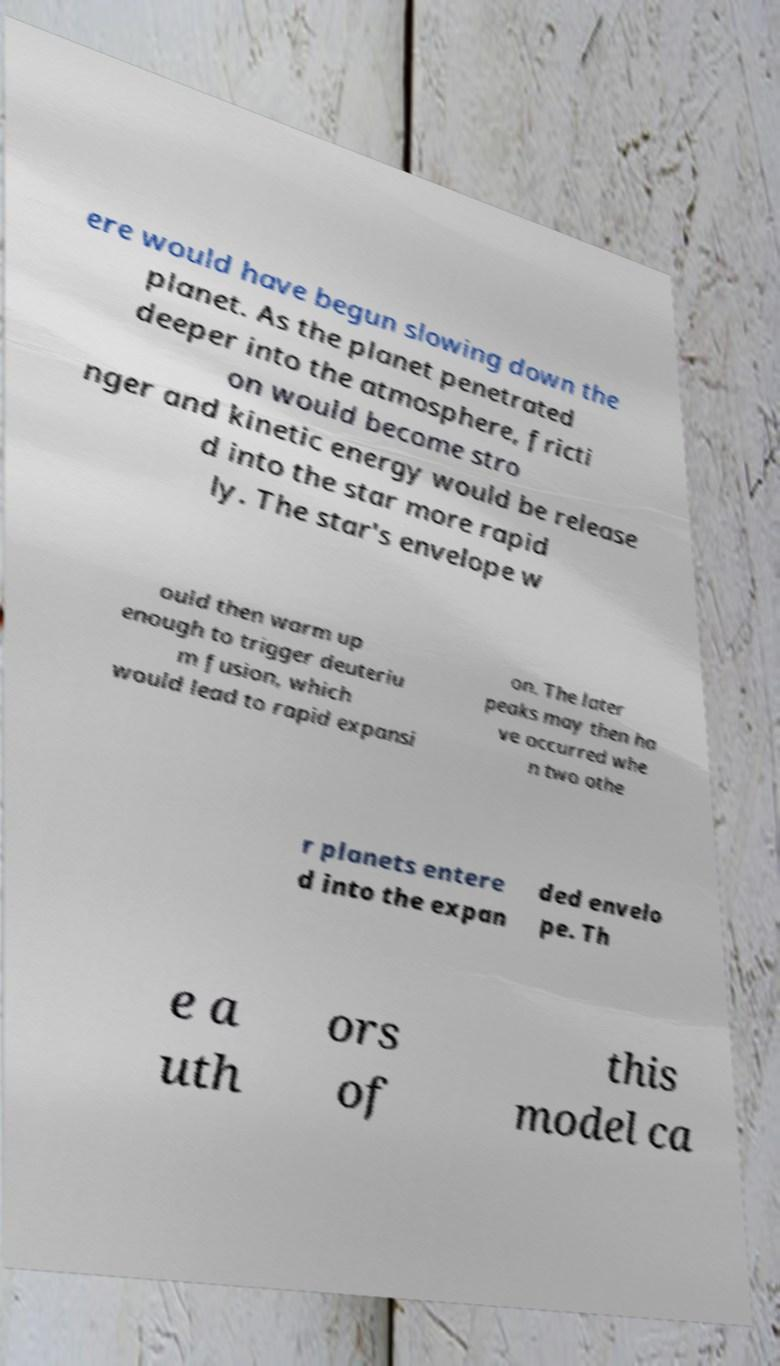Could you extract and type out the text from this image? ere would have begun slowing down the planet. As the planet penetrated deeper into the atmosphere, fricti on would become stro nger and kinetic energy would be release d into the star more rapid ly. The star's envelope w ould then warm up enough to trigger deuteriu m fusion, which would lead to rapid expansi on. The later peaks may then ha ve occurred whe n two othe r planets entere d into the expan ded envelo pe. Th e a uth ors of this model ca 